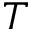Convert formula to latex. <formula><loc_0><loc_0><loc_500><loc_500>T</formula> 